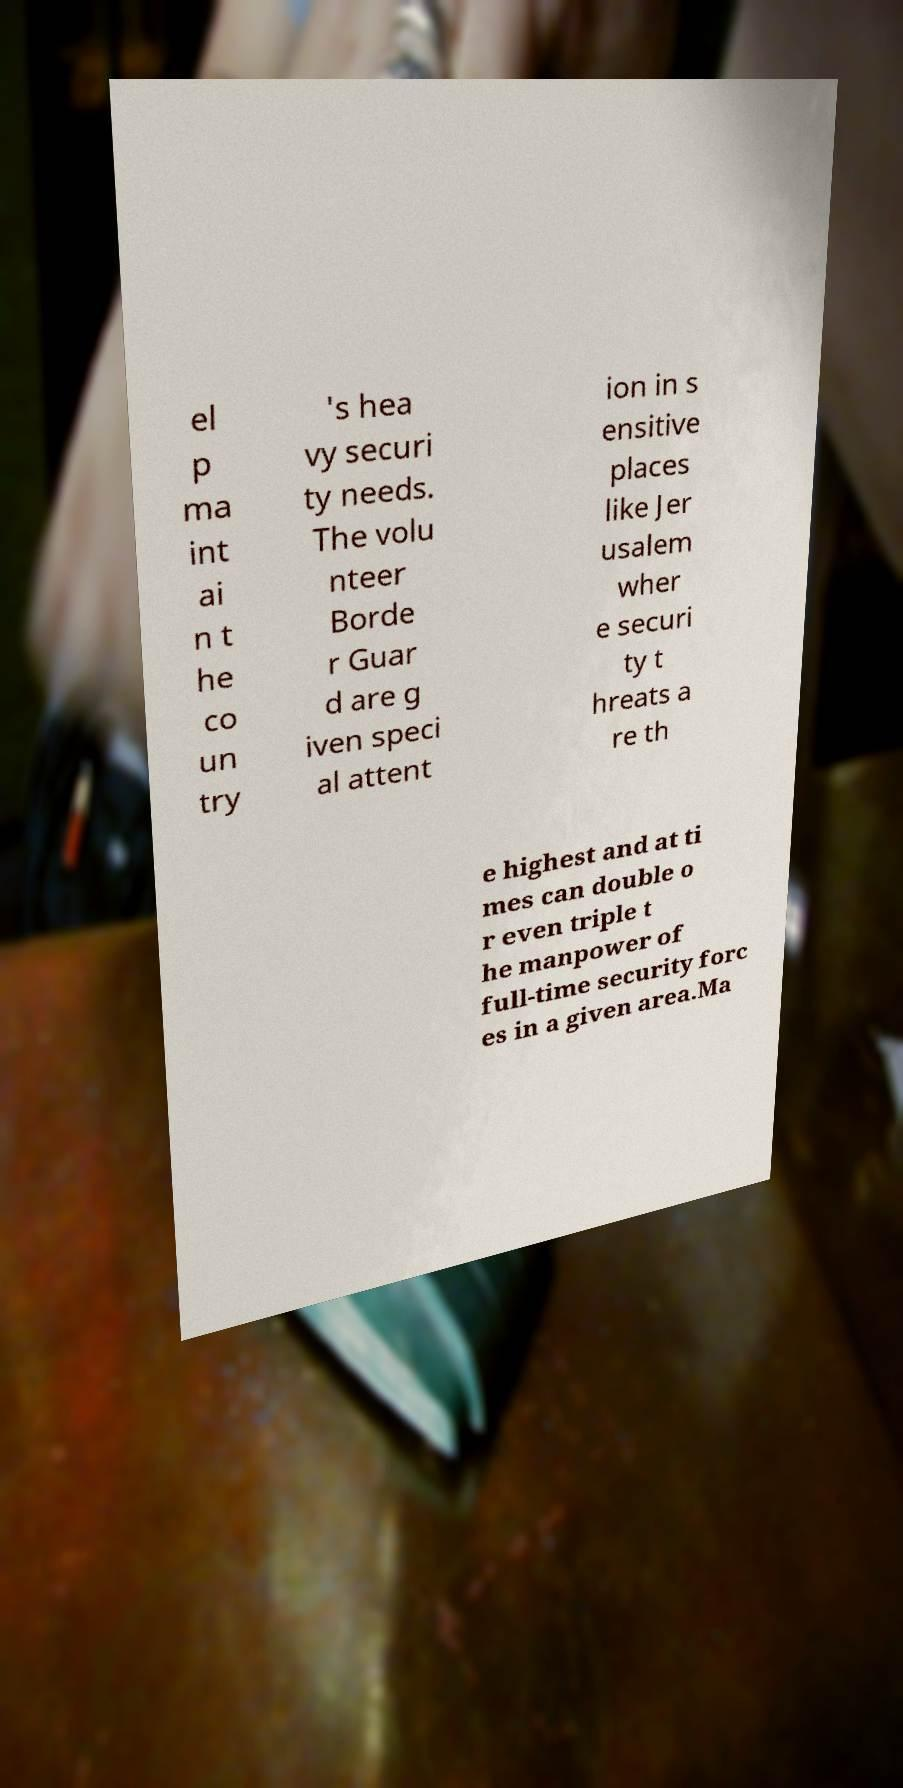There's text embedded in this image that I need extracted. Can you transcribe it verbatim? el p ma int ai n t he co un try 's hea vy securi ty needs. The volu nteer Borde r Guar d are g iven speci al attent ion in s ensitive places like Jer usalem wher e securi ty t hreats a re th e highest and at ti mes can double o r even triple t he manpower of full-time security forc es in a given area.Ma 